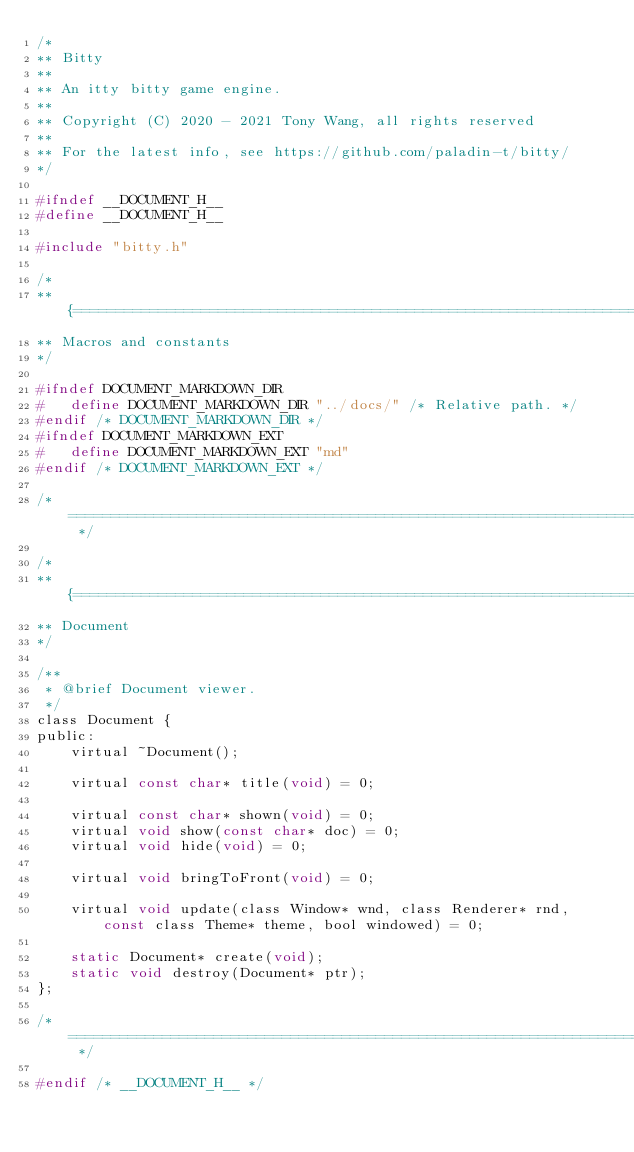Convert code to text. <code><loc_0><loc_0><loc_500><loc_500><_C_>/*
** Bitty
**
** An itty bitty game engine.
**
** Copyright (C) 2020 - 2021 Tony Wang, all rights reserved
**
** For the latest info, see https://github.com/paladin-t/bitty/
*/

#ifndef __DOCUMENT_H__
#define __DOCUMENT_H__

#include "bitty.h"

/*
** {===========================================================================
** Macros and constants
*/

#ifndef DOCUMENT_MARKDOWN_DIR
#	define DOCUMENT_MARKDOWN_DIR "../docs/" /* Relative path. */
#endif /* DOCUMENT_MARKDOWN_DIR */
#ifndef DOCUMENT_MARKDOWN_EXT
#	define DOCUMENT_MARKDOWN_EXT "md"
#endif /* DOCUMENT_MARKDOWN_EXT */

/* ===========================================================================} */

/*
** {===========================================================================
** Document
*/

/**
 * @brief Document viewer.
 */
class Document {
public:
	virtual ~Document();

	virtual const char* title(void) = 0;

	virtual const char* shown(void) = 0;
	virtual void show(const char* doc) = 0;
	virtual void hide(void) = 0;

	virtual void bringToFront(void) = 0;

	virtual void update(class Window* wnd, class Renderer* rnd, const class Theme* theme, bool windowed) = 0;

	static Document* create(void);
	static void destroy(Document* ptr);
};

/* ===========================================================================} */

#endif /* __DOCUMENT_H__ */
</code> 